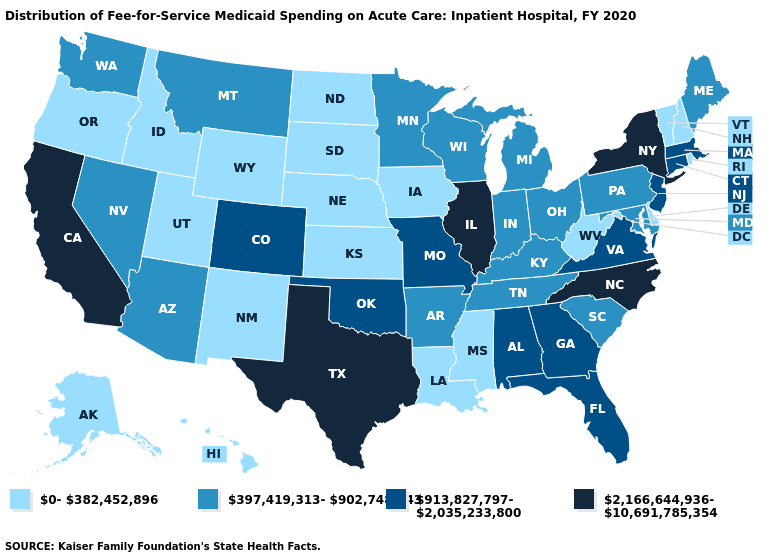Does North Carolina have the lowest value in the USA?
Concise answer only. No. Name the states that have a value in the range 0-382,452,896?
Short answer required. Alaska, Delaware, Hawaii, Idaho, Iowa, Kansas, Louisiana, Mississippi, Nebraska, New Hampshire, New Mexico, North Dakota, Oregon, Rhode Island, South Dakota, Utah, Vermont, West Virginia, Wyoming. Name the states that have a value in the range 0-382,452,896?
Quick response, please. Alaska, Delaware, Hawaii, Idaho, Iowa, Kansas, Louisiana, Mississippi, Nebraska, New Hampshire, New Mexico, North Dakota, Oregon, Rhode Island, South Dakota, Utah, Vermont, West Virginia, Wyoming. Does North Carolina have the highest value in the USA?
Quick response, please. Yes. Does Hawaii have the highest value in the USA?
Keep it brief. No. Name the states that have a value in the range 397,419,313-902,748,343?
Write a very short answer. Arizona, Arkansas, Indiana, Kentucky, Maine, Maryland, Michigan, Minnesota, Montana, Nevada, Ohio, Pennsylvania, South Carolina, Tennessee, Washington, Wisconsin. What is the value of South Carolina?
Concise answer only. 397,419,313-902,748,343. Does the first symbol in the legend represent the smallest category?
Be succinct. Yes. Which states hav the highest value in the West?
Write a very short answer. California. Does Vermont have the lowest value in the USA?
Quick response, please. Yes. Does Alaska have the same value as Maryland?
Quick response, please. No. What is the value of Arizona?
Answer briefly. 397,419,313-902,748,343. What is the value of Texas?
Give a very brief answer. 2,166,644,936-10,691,785,354. 